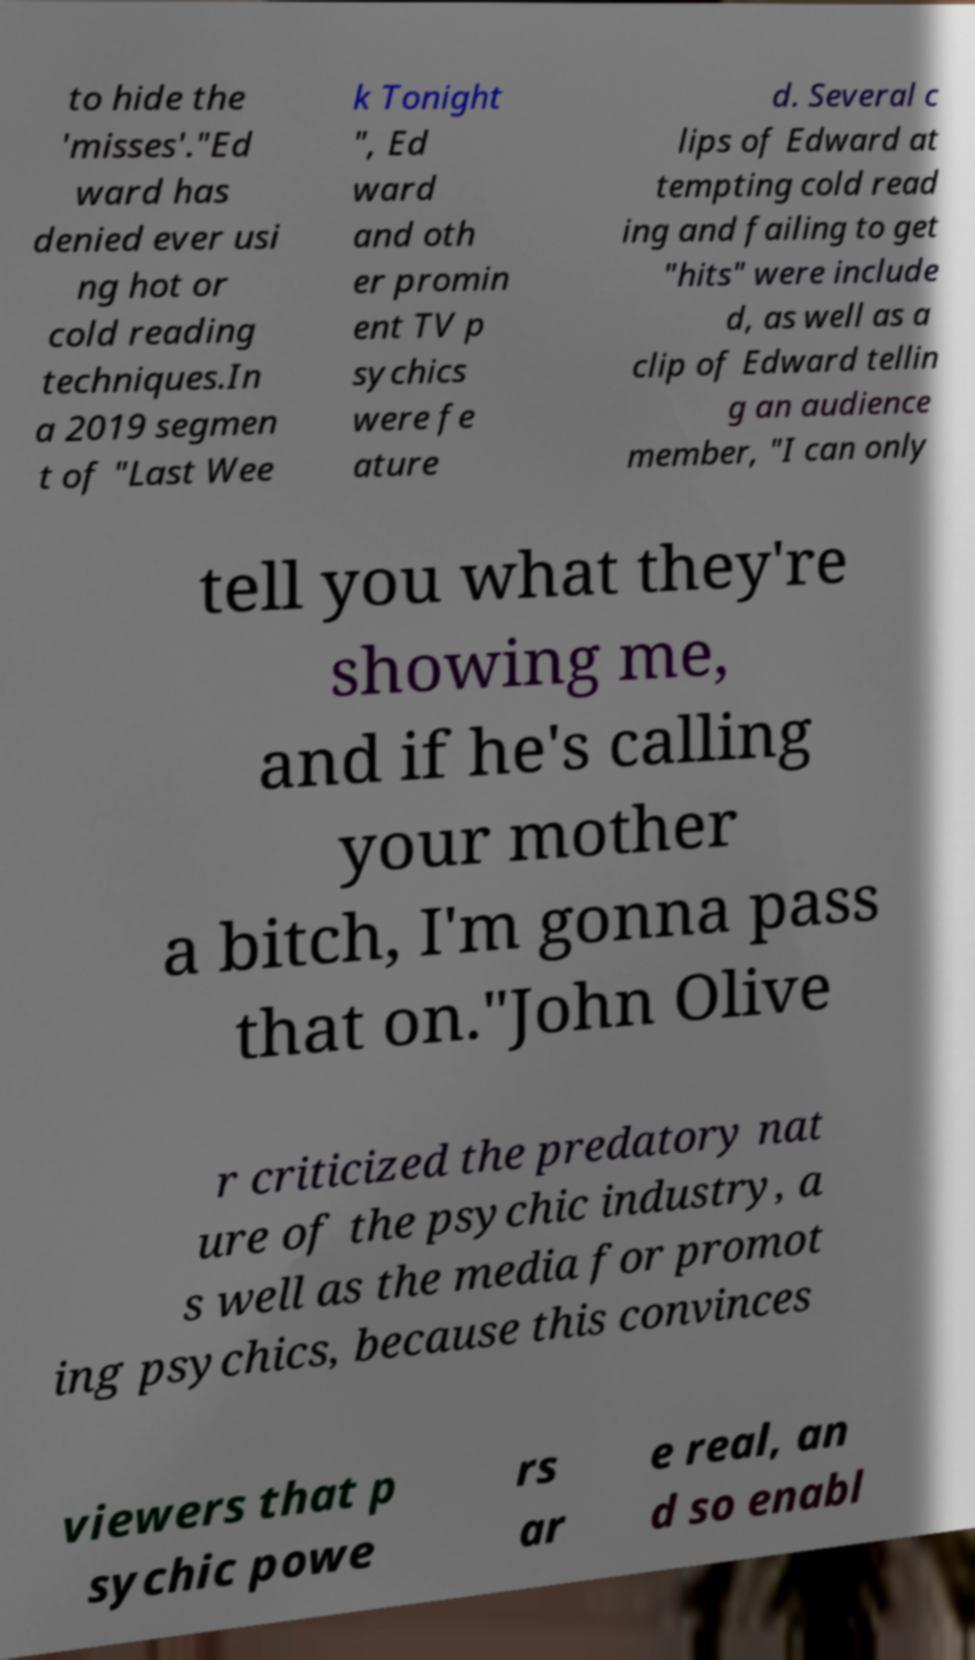There's text embedded in this image that I need extracted. Can you transcribe it verbatim? to hide the 'misses'."Ed ward has denied ever usi ng hot or cold reading techniques.In a 2019 segmen t of "Last Wee k Tonight ", Ed ward and oth er promin ent TV p sychics were fe ature d. Several c lips of Edward at tempting cold read ing and failing to get "hits" were include d, as well as a clip of Edward tellin g an audience member, "I can only tell you what they're showing me, and if he's calling your mother a bitch, I'm gonna pass that on."John Olive r criticized the predatory nat ure of the psychic industry, a s well as the media for promot ing psychics, because this convinces viewers that p sychic powe rs ar e real, an d so enabl 